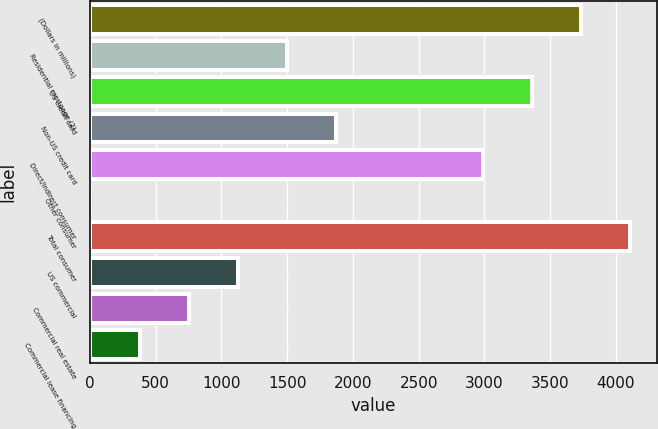Convert chart to OTSL. <chart><loc_0><loc_0><loc_500><loc_500><bar_chart><fcel>(Dollars in millions)<fcel>Residential mortgage (2)<fcel>US credit card<fcel>Non-US credit card<fcel>Direct/Indirect consumer<fcel>Other consumer<fcel>Total consumer<fcel>US commercial<fcel>Commercial real estate<fcel>Commercial lease financing<nl><fcel>3736<fcel>1496.8<fcel>3362.8<fcel>1870<fcel>2989.6<fcel>4<fcel>4109.2<fcel>1123.6<fcel>750.4<fcel>377.2<nl></chart> 